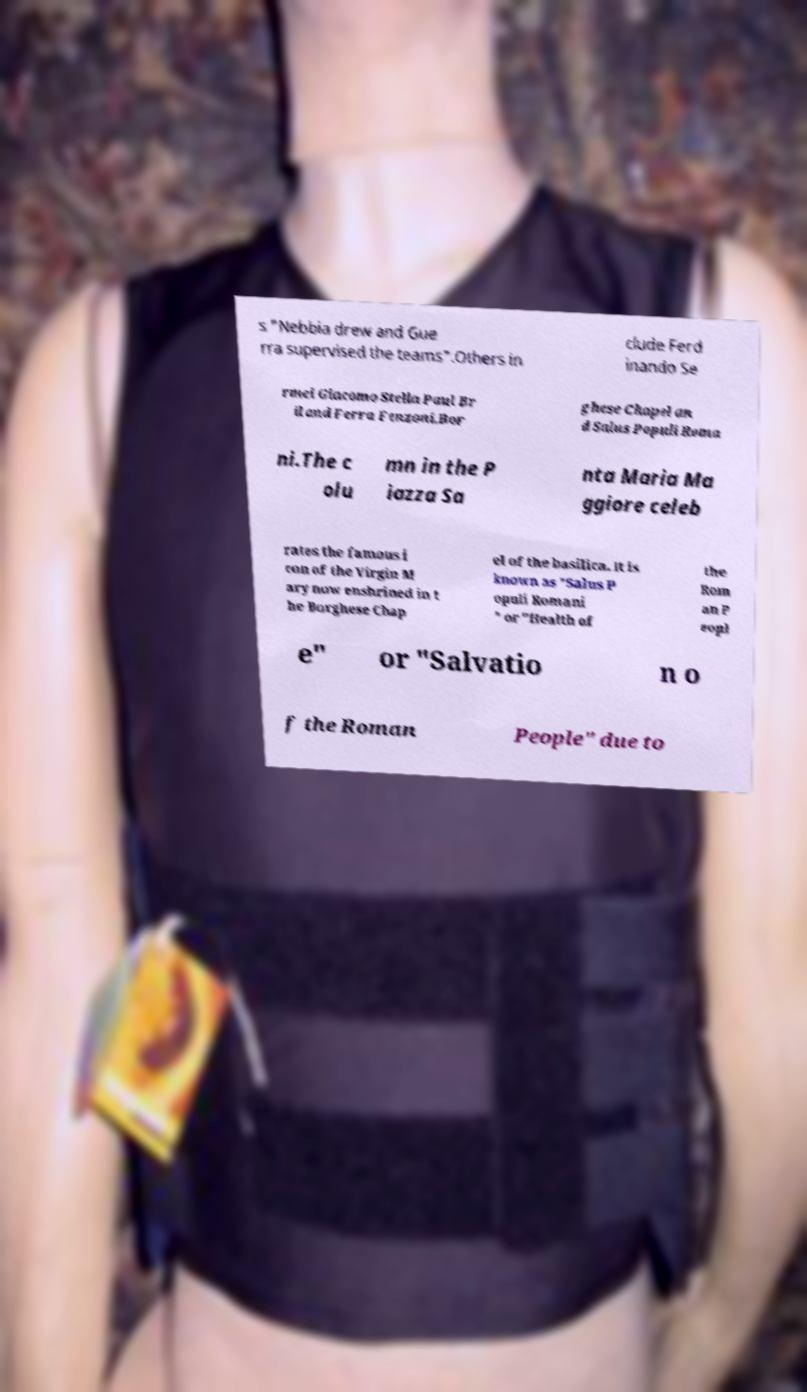Could you assist in decoding the text presented in this image and type it out clearly? s "Nebbia drew and Gue rra supervised the teams".Others in clude Ferd inando Se rmei Giacomo Stella Paul Br il and Ferra Fenzoni.Bor ghese Chapel an d Salus Populi Roma ni.The c olu mn in the P iazza Sa nta Maria Ma ggiore celeb rates the famous i con of the Virgin M ary now enshrined in t he Borghese Chap el of the basilica. It is known as "Salus P opuli Romani " or "Health of the Rom an P eopl e" or "Salvatio n o f the Roman People" due to 